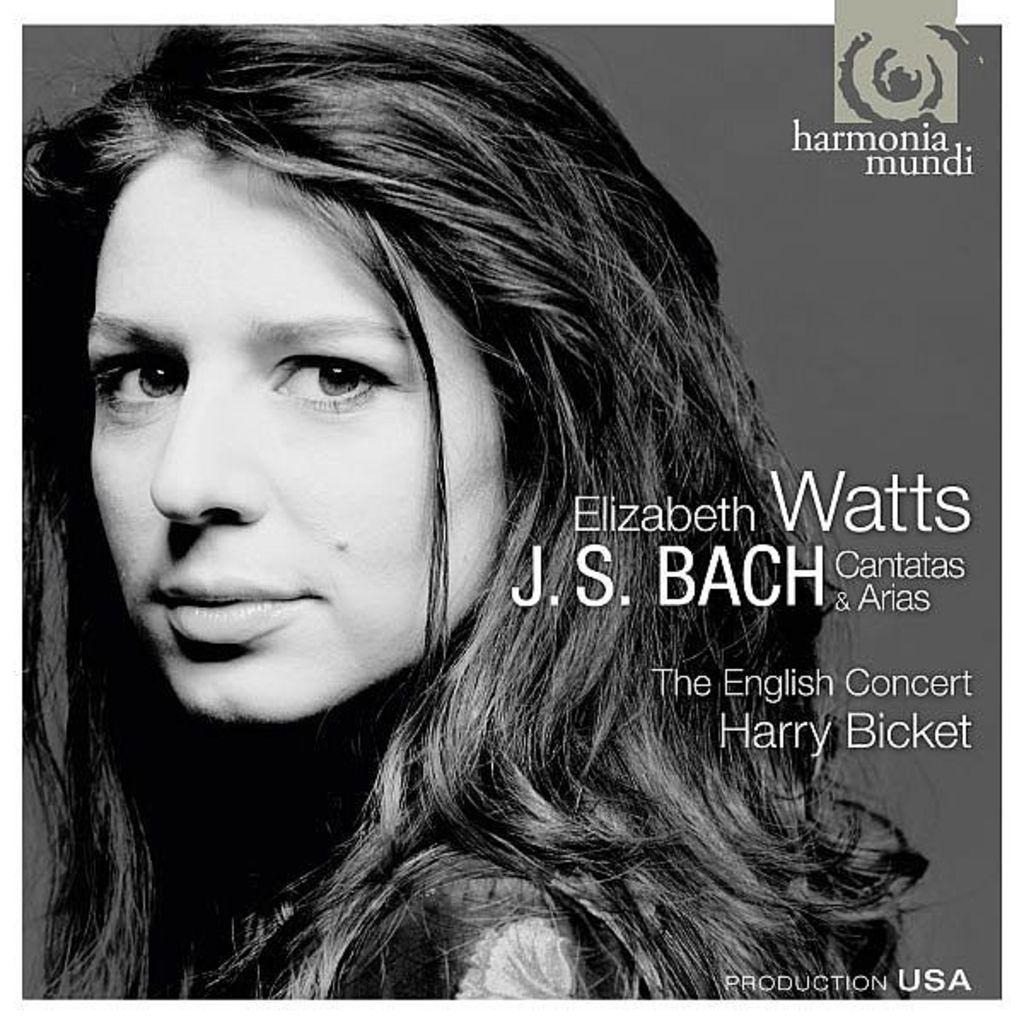What is the color scheme of the image? The image is black and white. Where is the woman located in the image? The woman is on the left side of the image. What is the woman doing in the image? The woman is looking at a picture. What can be seen on the right side of the image? There is text on the right side of the image. What type of substance is being used to create humor in the image? There is no substance or humor present in the image; it is a black and white image of a woman looking at a picture with text on the right side. 